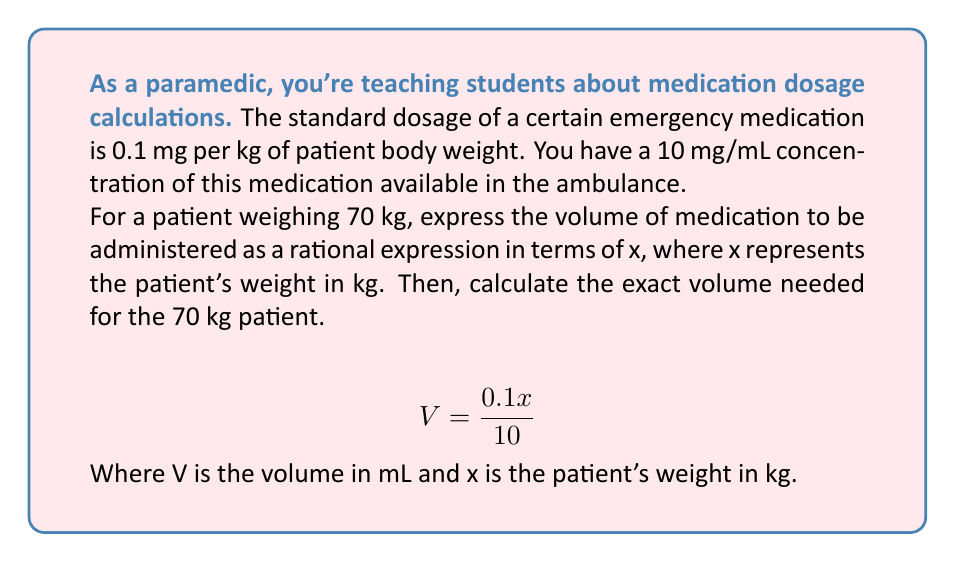Could you help me with this problem? Let's approach this step-by-step:

1) First, we need to understand the given information:
   - Dosage: 0.1 mg per kg of body weight
   - Concentration: 10 mg/mL
   - Patient weight: 70 kg

2) To create a rational expression, we'll use x to represent the patient's weight in kg:
   
   $$\text{Dosage (mg)} = 0.1x$$

3) Now, we need to convert this dosage to a volume. We can do this by dividing the dosage by the concentration:

   $$V = \frac{\text{Dosage (mg)}}{\text{Concentration (mg/mL)}} = \frac{0.1x}{10}$$

4) This is our rational expression for the volume of medication in terms of patient weight x.

5) To calculate the exact volume for a 70 kg patient, we substitute x = 70:

   $$V = \frac{0.1(70)}{10} = \frac{7}{10} = 0.7$$

Therefore, for a 70 kg patient, we need to administer 0.7 mL of the medication.
Answer: 0.7 mL 